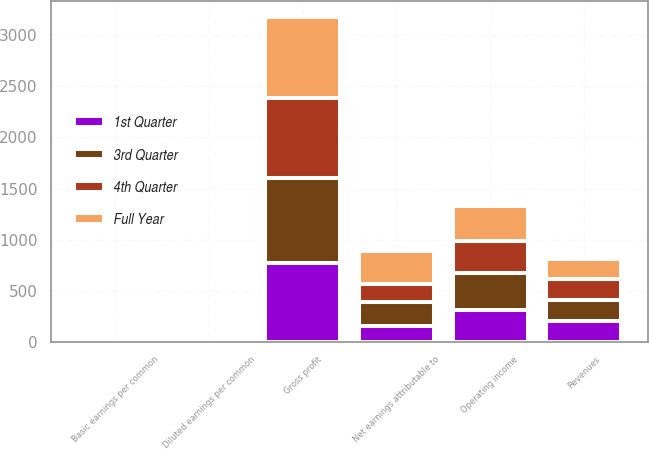Convert chart to OTSL. <chart><loc_0><loc_0><loc_500><loc_500><stacked_bar_chart><ecel><fcel>Revenues<fcel>Gross profit<fcel>Operating income<fcel>Net earnings attributable to<fcel>Basic earnings per common<fcel>Diluted earnings per common<nl><fcel>4th Quarter<fcel>203.5<fcel>779<fcel>305.4<fcel>173.2<fcel>1.7<fcel>1.67<nl><fcel>3rd Quarter<fcel>203.5<fcel>835.1<fcel>369.2<fcel>233.8<fcel>2.29<fcel>2.27<nl><fcel>Full Year<fcel>203.5<fcel>789.9<fcel>343.4<fcel>318.8<fcel>3.14<fcel>3.1<nl><fcel>1st Quarter<fcel>203.5<fcel>772.4<fcel>307.7<fcel>157.9<fcel>1.58<fcel>1.56<nl></chart> 